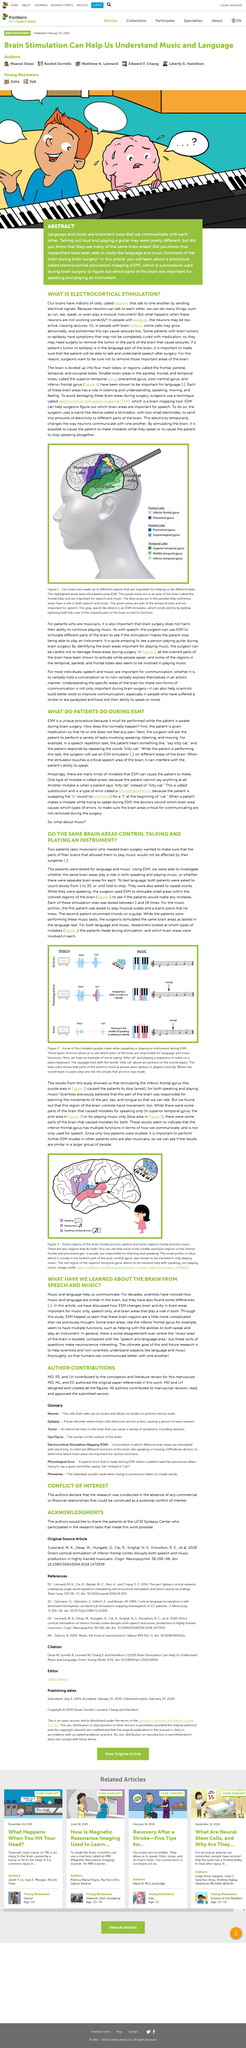Identify some key points in this picture. Neurons are cells in the brain that play a crucial role in the functioning of the nervous system. Two musicians play the piano and guitar, respectively. Previously, scientists believed that the purple area in Figure 1 was responsible for planning the movements of the jaw, lips, and tongue. The number of patients studied was 2.. Neurons play a critical role in enabling us to perform various complex tasks, such as running, eating, speaking, and even playing a musical instrument. 